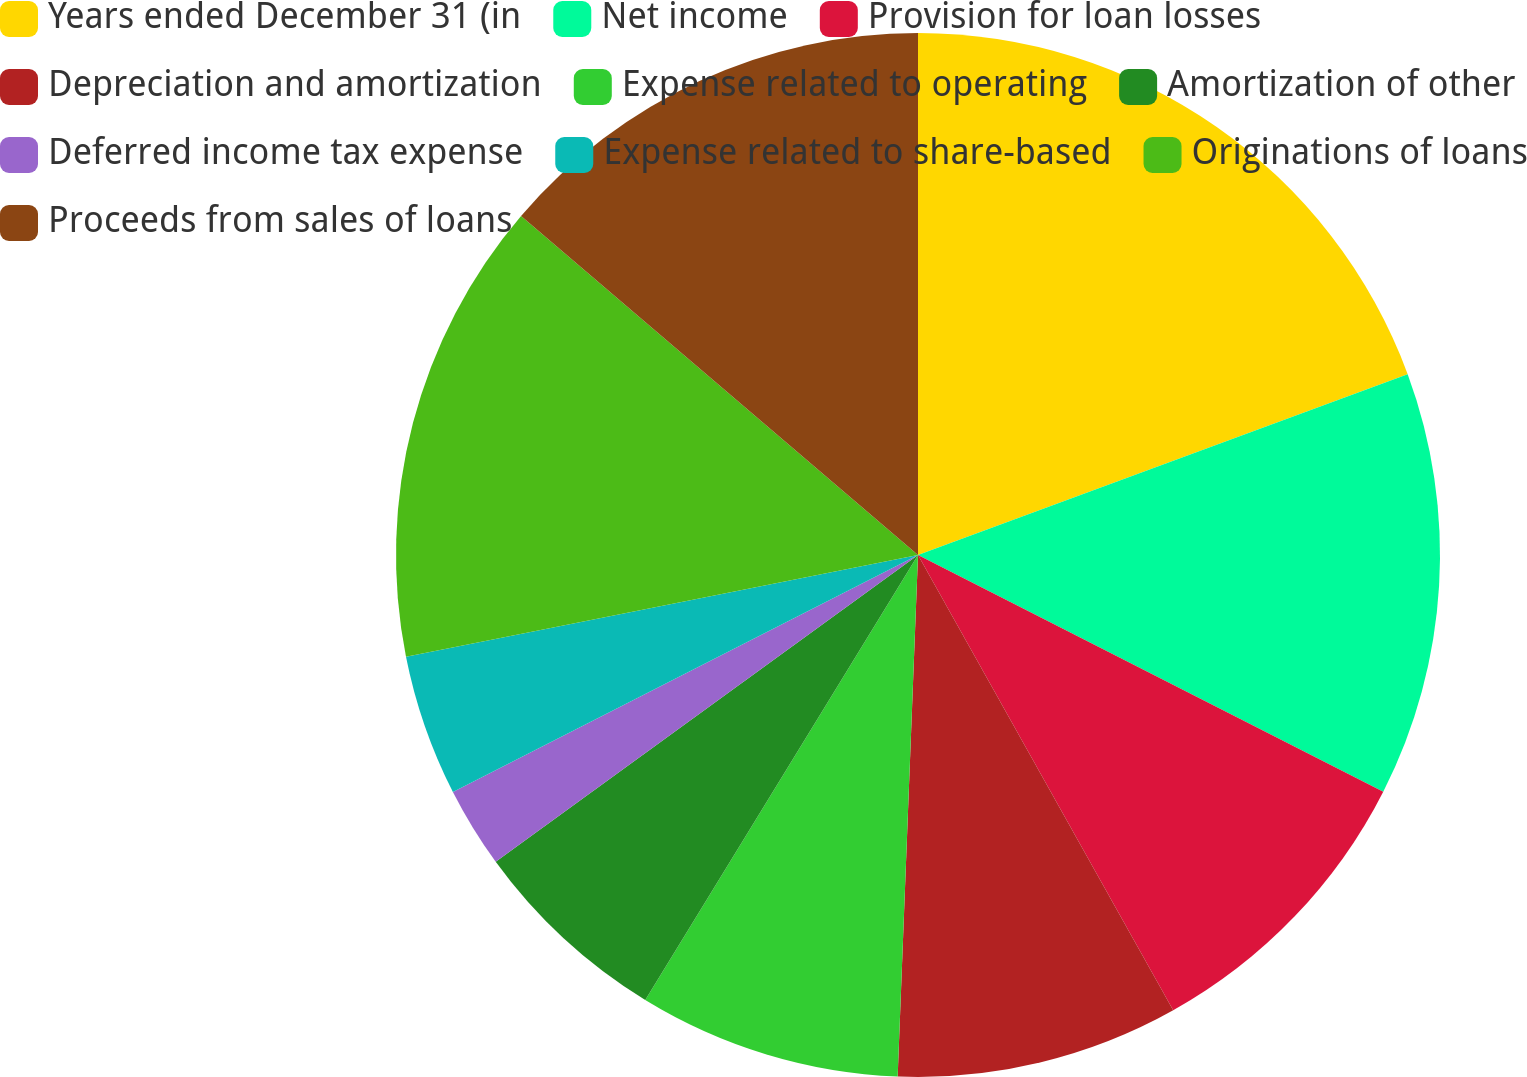Convert chart to OTSL. <chart><loc_0><loc_0><loc_500><loc_500><pie_chart><fcel>Years ended December 31 (in<fcel>Net income<fcel>Provision for loan losses<fcel>Depreciation and amortization<fcel>Expense related to operating<fcel>Amortization of other<fcel>Deferred income tax expense<fcel>Expense related to share-based<fcel>Originations of loans<fcel>Proceeds from sales of loans<nl><fcel>19.37%<fcel>13.12%<fcel>9.38%<fcel>8.75%<fcel>8.13%<fcel>6.25%<fcel>2.5%<fcel>4.38%<fcel>14.37%<fcel>13.75%<nl></chart> 